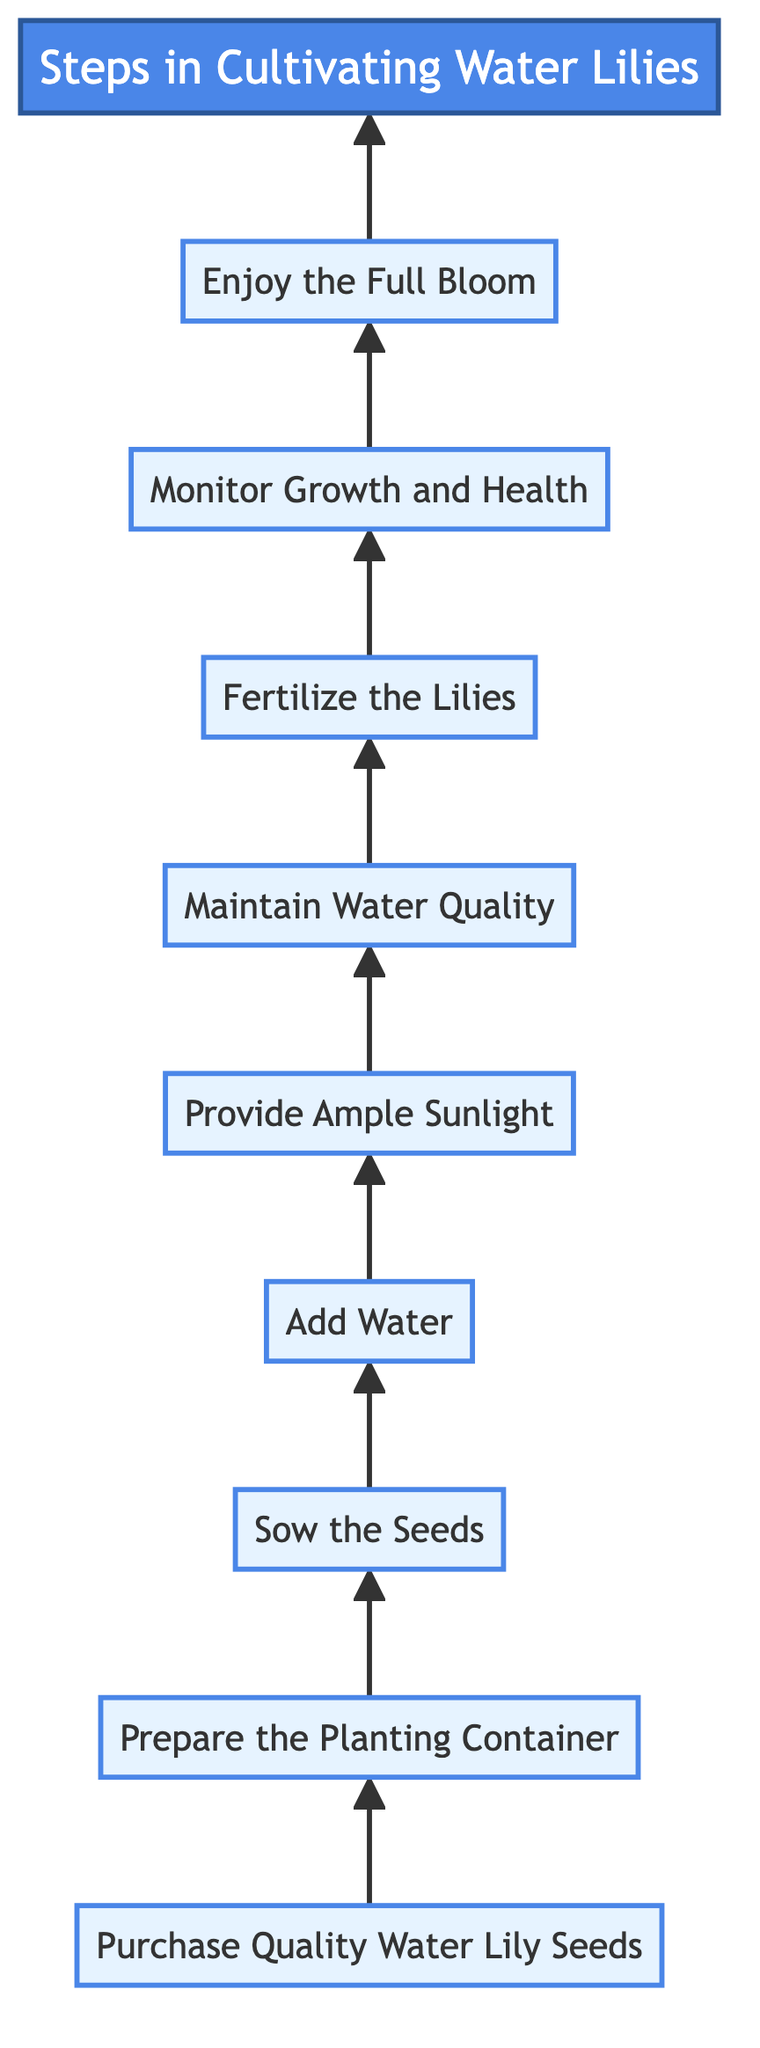What is the first step depicted in the diagram? The diagram starts with the first node labeled "Purchase Quality Water Lily Seeds," which represents the initial step in the cultivation process.
Answer: Purchase Quality Water Lily Seeds How many total steps are there in the cultivation process? By counting the steps listed in the diagram, there are a total of nine distinct steps that guide the cultivation of water lilies.
Answer: 9 What follows after “Sow the Seeds”? In the flow of steps, after "Sow the Seeds," the next step is "Add Water," which is shown as the succeeding node in the diagram.
Answer: Add Water What is the last step before enjoying the full bloom? The second last step is "Monitor Growth and Health," which is crucial before reaching the final stage of enjoying the full bloom of the water lilies.
Answer: Monitor Growth and Health Which step requires the use of fertilizer? The step that requires the use of fertilizer is "Fertilize the Lilies," indicated in the diagram as a necessary action during the growing season for robust growth.
Answer: Fertilize the Lilies What action is needed to maintain water quality? The relevant action for maintaining water quality, as outlined in the diagram, is to "Regularly check the water level and replace the water every two weeks."
Answer: Regularly check the water level and replace the water Which steps involve interactions with sunlight? The interaction with sunlight is represented in the step titled "Provide Ample Sunlight," which emphasizes the need for direct sunlight for the growth of water lilies.
Answer: Provide Ample Sunlight In what order do you add water and sunlight? According to the flow of steps shown in the diagram, "Add Water" must be done before "Provide Ample Sunlight," indicating the sequence of these actions.
Answer: Add Water, Provide Ample Sunlight What type of diagram is represented? The diagram is a Bottom to Top Flow Chart, as indicated by the flow direction from bottom nodes to the top, showcasing the steps in a sequential manner.
Answer: Bottom to Top Flow Chart 